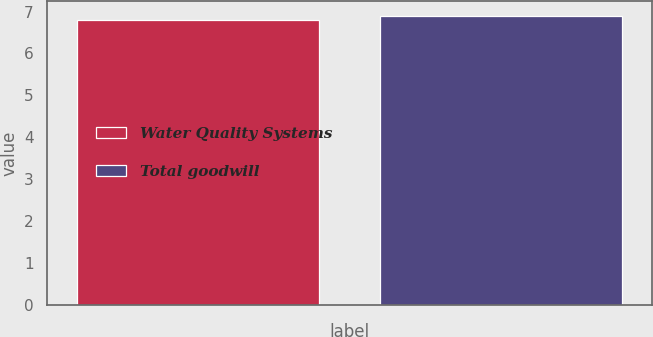<chart> <loc_0><loc_0><loc_500><loc_500><bar_chart><fcel>Water Quality Systems<fcel>Total goodwill<nl><fcel>6.8<fcel>6.9<nl></chart> 